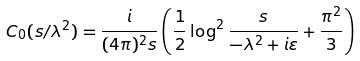<formula> <loc_0><loc_0><loc_500><loc_500>C _ { 0 } ( s / \lambda ^ { 2 } ) = \frac { i } { ( 4 \pi ) ^ { 2 } s } \left ( \frac { 1 } { 2 } \log ^ { 2 } \frac { s } { - \lambda ^ { 2 } + i \varepsilon } + \frac { \pi ^ { 2 } } { 3 } \right )</formula> 